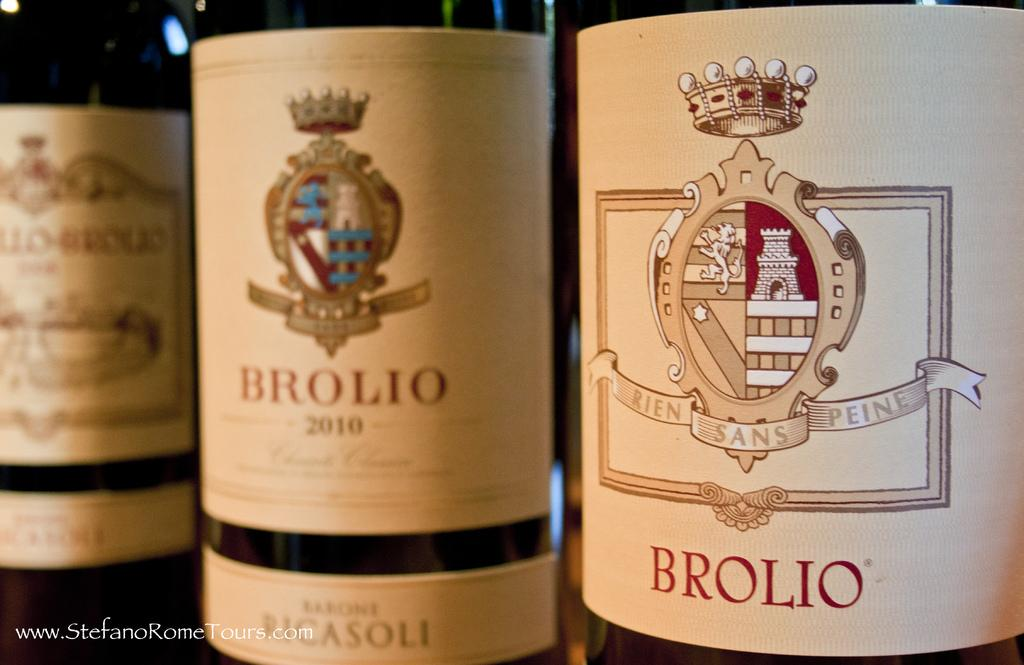<image>
Summarize the visual content of the image. The bottles of Brolio wine, including one with a 2010 vintage, are stood up next to each other. 